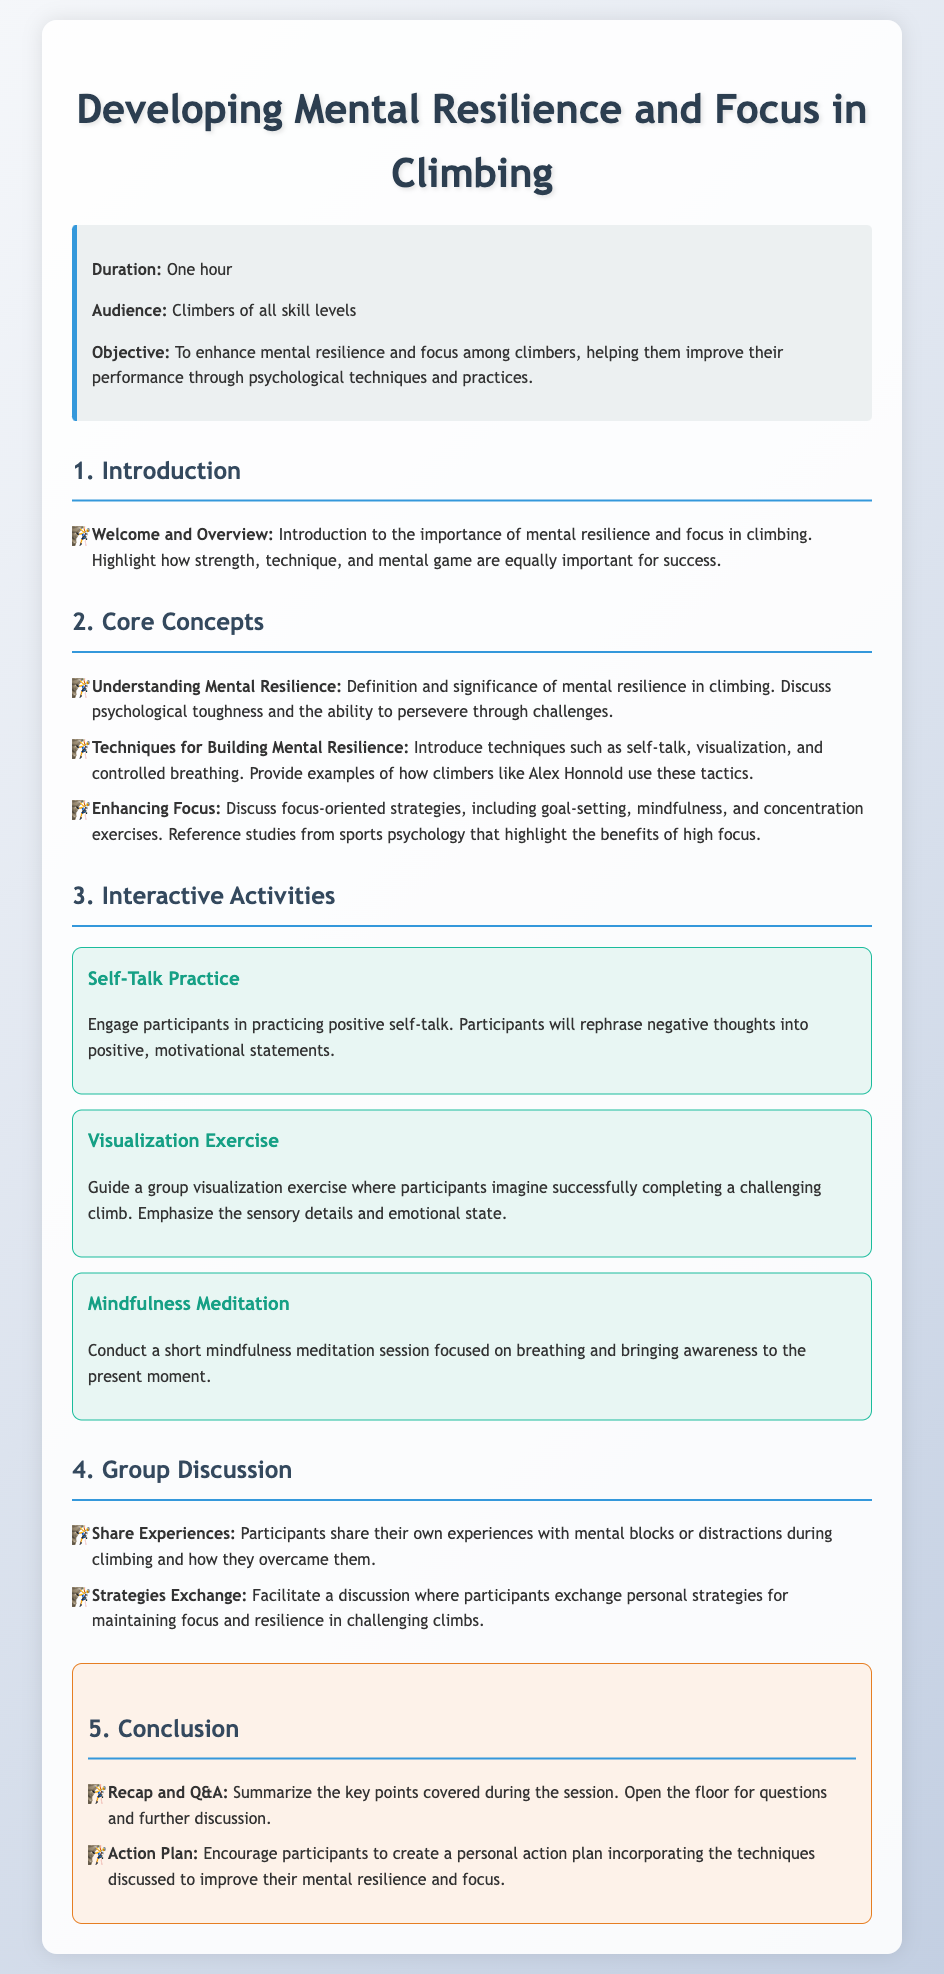What is the duration of the lesson? The duration of the lesson is explicitly stated in the document, which is one hour.
Answer: one hour Who is the audience for this lesson? The document specifies that the audience includes climbers of all skill levels.
Answer: climbers of all skill levels What is the objective of the lesson? The objective is clearly outlined in the document, aiming to enhance mental resilience and focus among climbers.
Answer: to enhance mental resilience and focus What is one technique for building mental resilience mentioned in the document? The document lists techniques like self-talk, visualization, and controlled breathing, which are specifically mentioned as ways to build mental resilience.
Answer: self-talk What activity involves practicing positive self-talk? The activity that focuses on positive self-talk is named "Self-Talk Practice."
Answer: Self-Talk Practice What key concept is discussed alongside focus-oriented strategies? The document mentions goal-setting alongside techniques for enhancing focus.
Answer: goal-setting What is a takeaway from the conclusion section of the lesson? One of the takeaways from the conclusion section is the encouragement for participants to create a personal action plan.
Answer: create a personal action plan What exercise involves guiding a group visualization? The exercise that guides a group visualization is called "Visualization Exercise."
Answer: Visualization Exercise What does the group discussion emphasize? The group discussion emphasizes sharing personal experiences related to mental blocks during climbing.
Answer: sharing personal experiences 